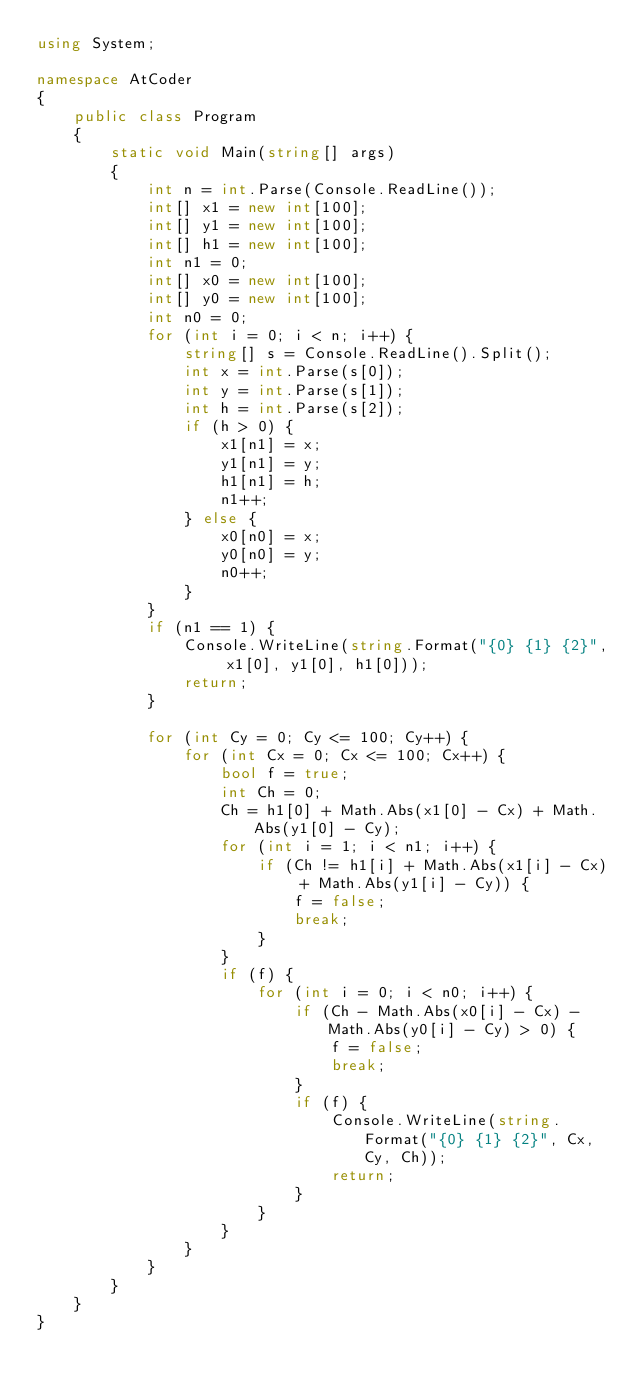<code> <loc_0><loc_0><loc_500><loc_500><_C#_>using System;

namespace AtCoder
{
	public class Program
	{
		static void Main(string[] args)
		{
			int n = int.Parse(Console.ReadLine());
			int[] x1 = new int[100];
			int[] y1 = new int[100];
			int[] h1 = new int[100];
			int n1 = 0;
			int[] x0 = new int[100];
			int[] y0 = new int[100];
			int n0 = 0;
			for (int i = 0; i < n; i++) {
				string[] s = Console.ReadLine().Split();
				int x = int.Parse(s[0]);
				int y = int.Parse(s[1]);
				int h = int.Parse(s[2]);
				if (h > 0) {
					x1[n1] = x;
					y1[n1] = y;
					h1[n1] = h;
					n1++;
				} else {
					x0[n0] = x;
					y0[n0] = y;
					n0++;
				}
			}
			if (n1 == 1) {
				Console.WriteLine(string.Format("{0} {1} {2}", x1[0], y1[0], h1[0]));
				return;
			}

			for (int Cy = 0; Cy <= 100; Cy++) {
				for (int Cx = 0; Cx <= 100; Cx++) {
					bool f = true;
					int Ch = 0;
					Ch = h1[0] + Math.Abs(x1[0] - Cx) + Math.Abs(y1[0] - Cy);
					for (int i = 1; i < n1; i++) {
						if (Ch != h1[i] + Math.Abs(x1[i] - Cx) + Math.Abs(y1[i] - Cy)) {
							f = false;
							break;
						}
					}
					if (f) {
						for (int i = 0; i < n0; i++) {
							if (Ch - Math.Abs(x0[i] - Cx) - Math.Abs(y0[i] - Cy) > 0) {
								f = false;
								break;
							}
							if (f) {
								Console.WriteLine(string.Format("{0} {1} {2}", Cx, Cy, Ch));
								return;
							}
						}
					}
				}
			}
		}
	}
}</code> 